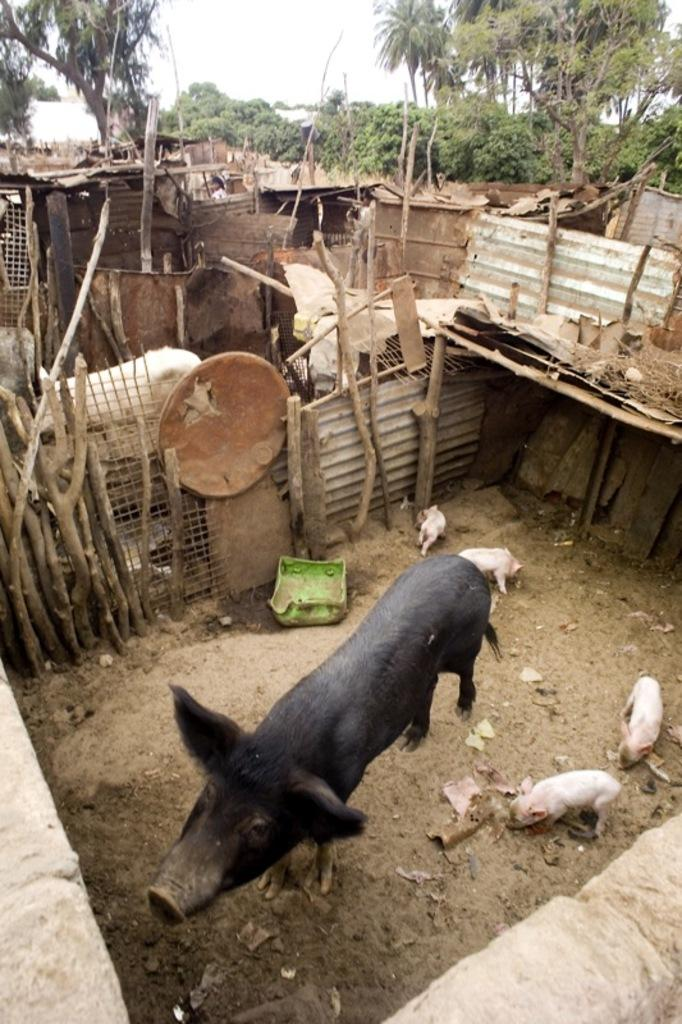What types of living organisms can be seen in the image? There are animals in the image. What can be seen in the background of the image? There are trees in the image. What type of barrier is present in the image? There is a fence in the image. What other objects can be seen in the image? There are wooden logs in the image. What emotion is the grandmother expressing in the image? There is no grandmother present in the image. How many planes can be seen flying in the image? There are no planes visible in the image. 